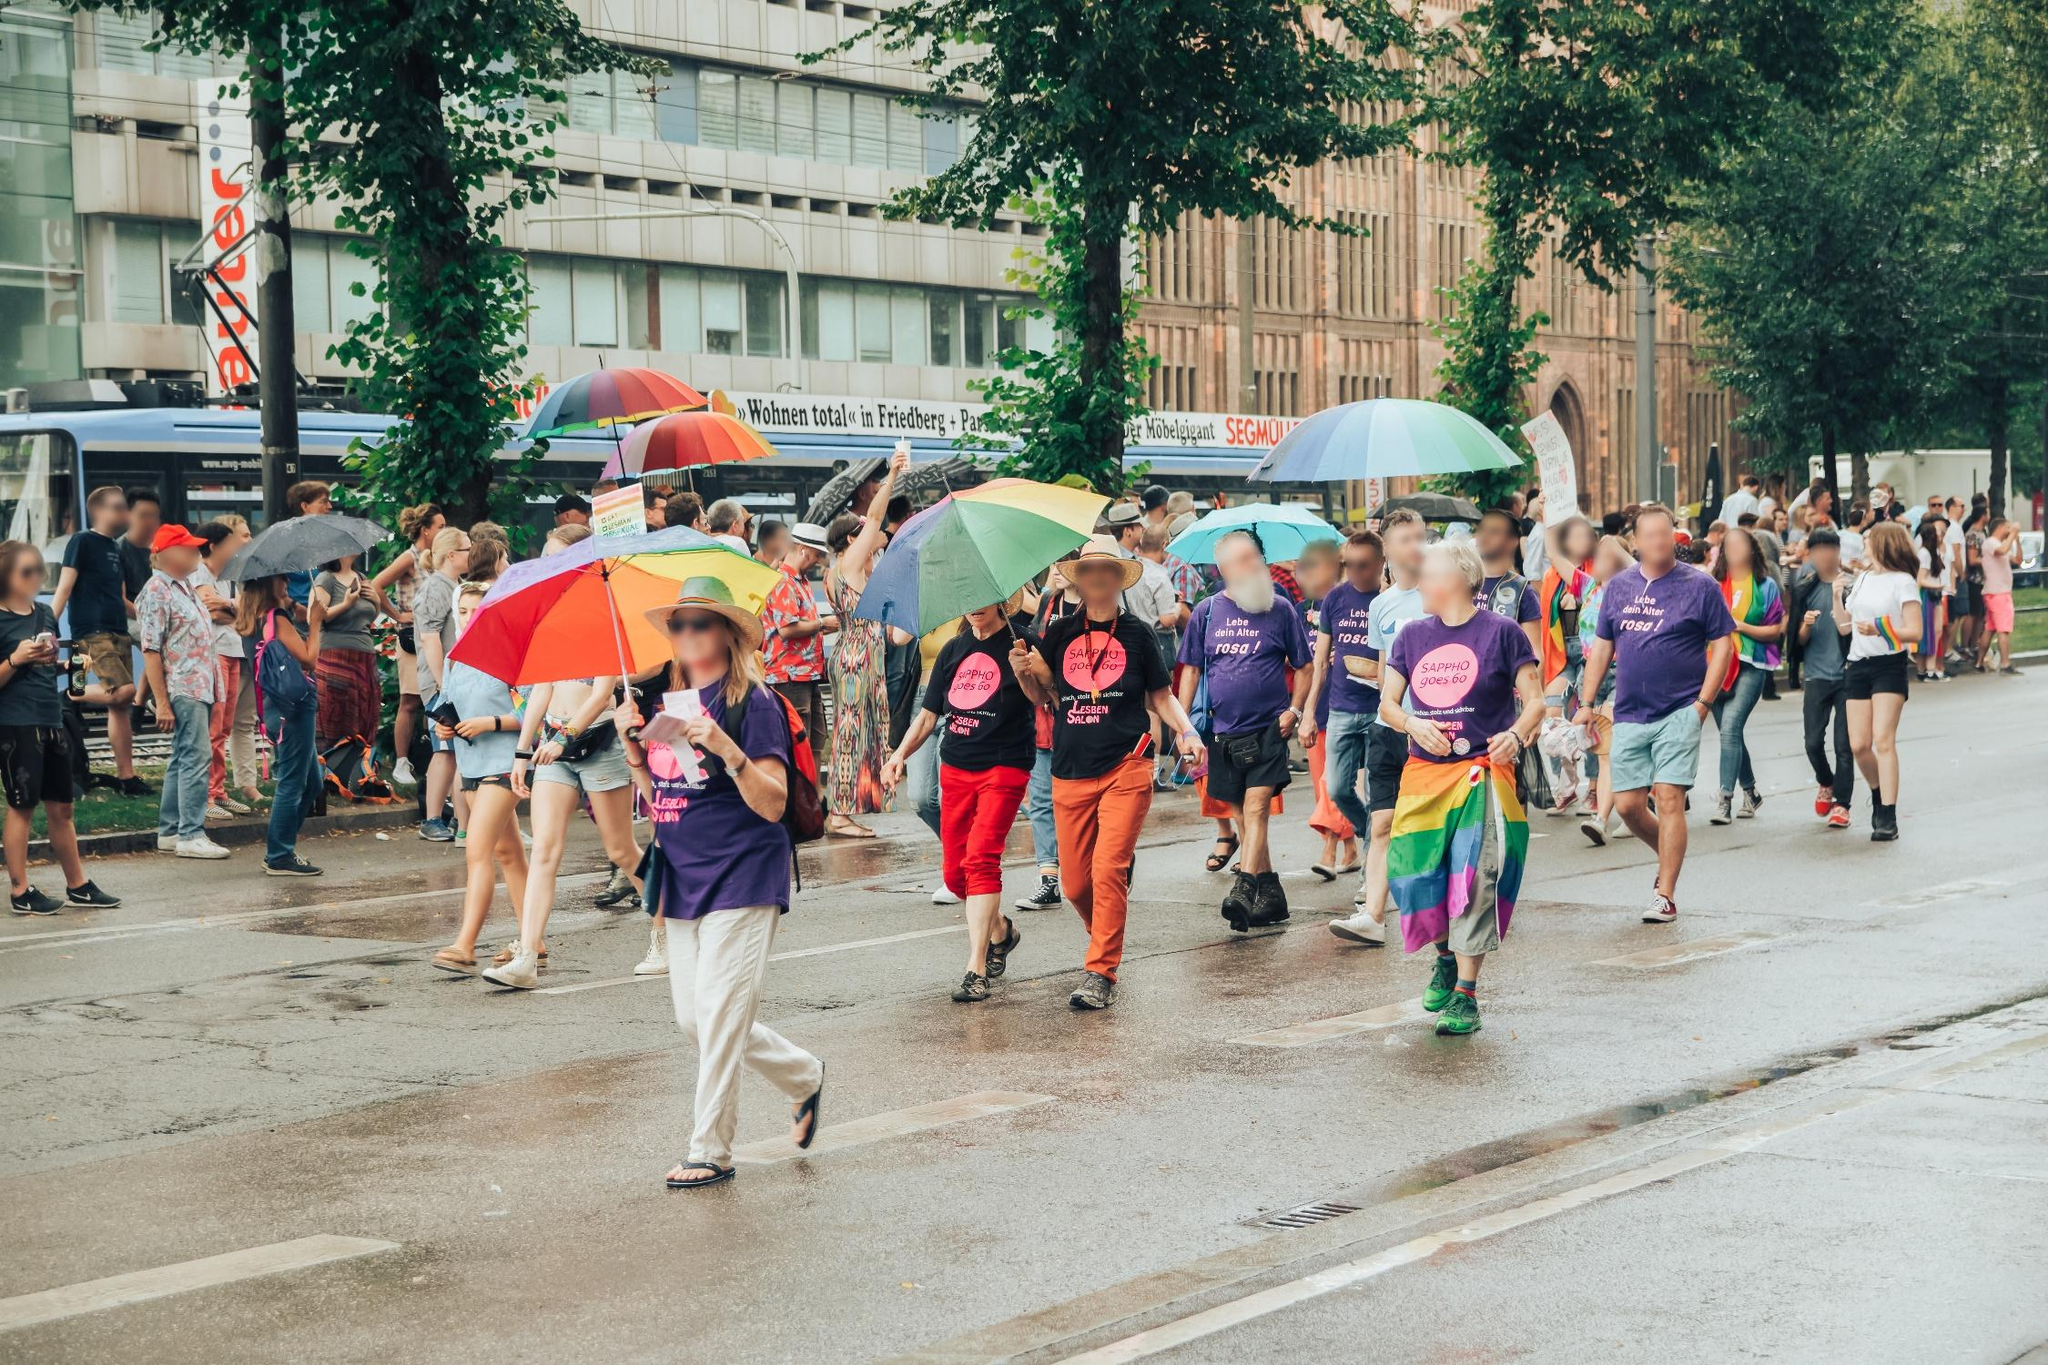Can you tell a story about an inspiring moment that could take place during this event? During the parade, a shy teenager standing in the crowd notices the sea of rainbow flags and hears the chants of love and acceptance. As the parade passes, one of the participants notices the teen and offers them a small rainbow flag. With a hesitant smile, the teenager takes the flag and waves it gently. The crowd around the teen cheers, and for the first time, they feel the strength and warmth of community support. This moment of connection inspires the teenager to feel proud of who they are and more confident in expressing their true self. What are some potential challenges the participants might face during the parade? Participants might face challenges such as inclement weather, which is hinted at by some of the umbrellas. They may also encounter logistical issues, like navigating crowded streets or ensuring everyone stays safe and hydrated. Despite these challenges, the spirit of the event and the camaraderie among participants typically help overcome any obstacles, fostering a sense of resilience and unity. Let’s imagine a more whimsical scenario. Suppose this parade had an unexpected guest. What if a friendly dragon joined the parade? In a whimsical twist, imagine a friendly dragon joining the parade! As it soars above, its scales shimmer in vibrant colors that match the rainbow flags. Parading down the street, the dragon gently lands, its presence bringing gasps of amazement and delight from the crowd. The dragon, embodying the spirit of diversity and inclusion, interacts playfully with the participants, flapping its wings to create rainbows in the misty air. The parade becomes an even more magical celebration, with the dragon symbolizing the limitless possibilities and fantastical joy that come with acceptance and love. 